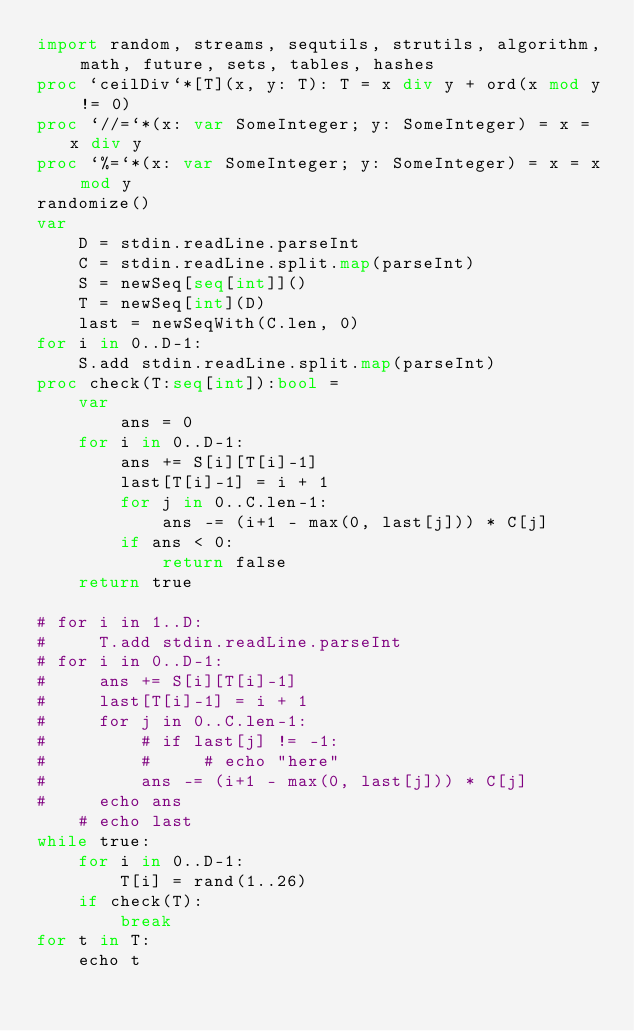<code> <loc_0><loc_0><loc_500><loc_500><_Nim_>import random, streams, sequtils, strutils, algorithm, math, future, sets, tables, hashes
proc `ceilDiv`*[T](x, y: T): T = x div y + ord(x mod y != 0)
proc `//=`*(x: var SomeInteger; y: SomeInteger) = x = x div y
proc `%=`*(x: var SomeInteger; y: SomeInteger) = x = x mod y
randomize()
var
    D = stdin.readLine.parseInt
    C = stdin.readLine.split.map(parseInt)
    S = newSeq[seq[int]]()
    T = newSeq[int](D)
    last = newSeqWith(C.len, 0)
for i in 0..D-1:
    S.add stdin.readLine.split.map(parseInt)
proc check(T:seq[int]):bool =
    var
        ans = 0
    for i in 0..D-1:
        ans += S[i][T[i]-1]
        last[T[i]-1] = i + 1
        for j in 0..C.len-1:
            ans -= (i+1 - max(0, last[j])) * C[j]
        if ans < 0:
            return false
    return true

# for i in 1..D:
#     T.add stdin.readLine.parseInt
# for i in 0..D-1:
#     ans += S[i][T[i]-1]
#     last[T[i]-1] = i + 1
#     for j in 0..C.len-1:
#         # if last[j] != -1:
#         #     # echo "here"
#         ans -= (i+1 - max(0, last[j])) * C[j]
#     echo ans
    # echo last
while true:
    for i in 0..D-1:
        T[i] = rand(1..26)
    if check(T):
        break
for t in T:
    echo t</code> 